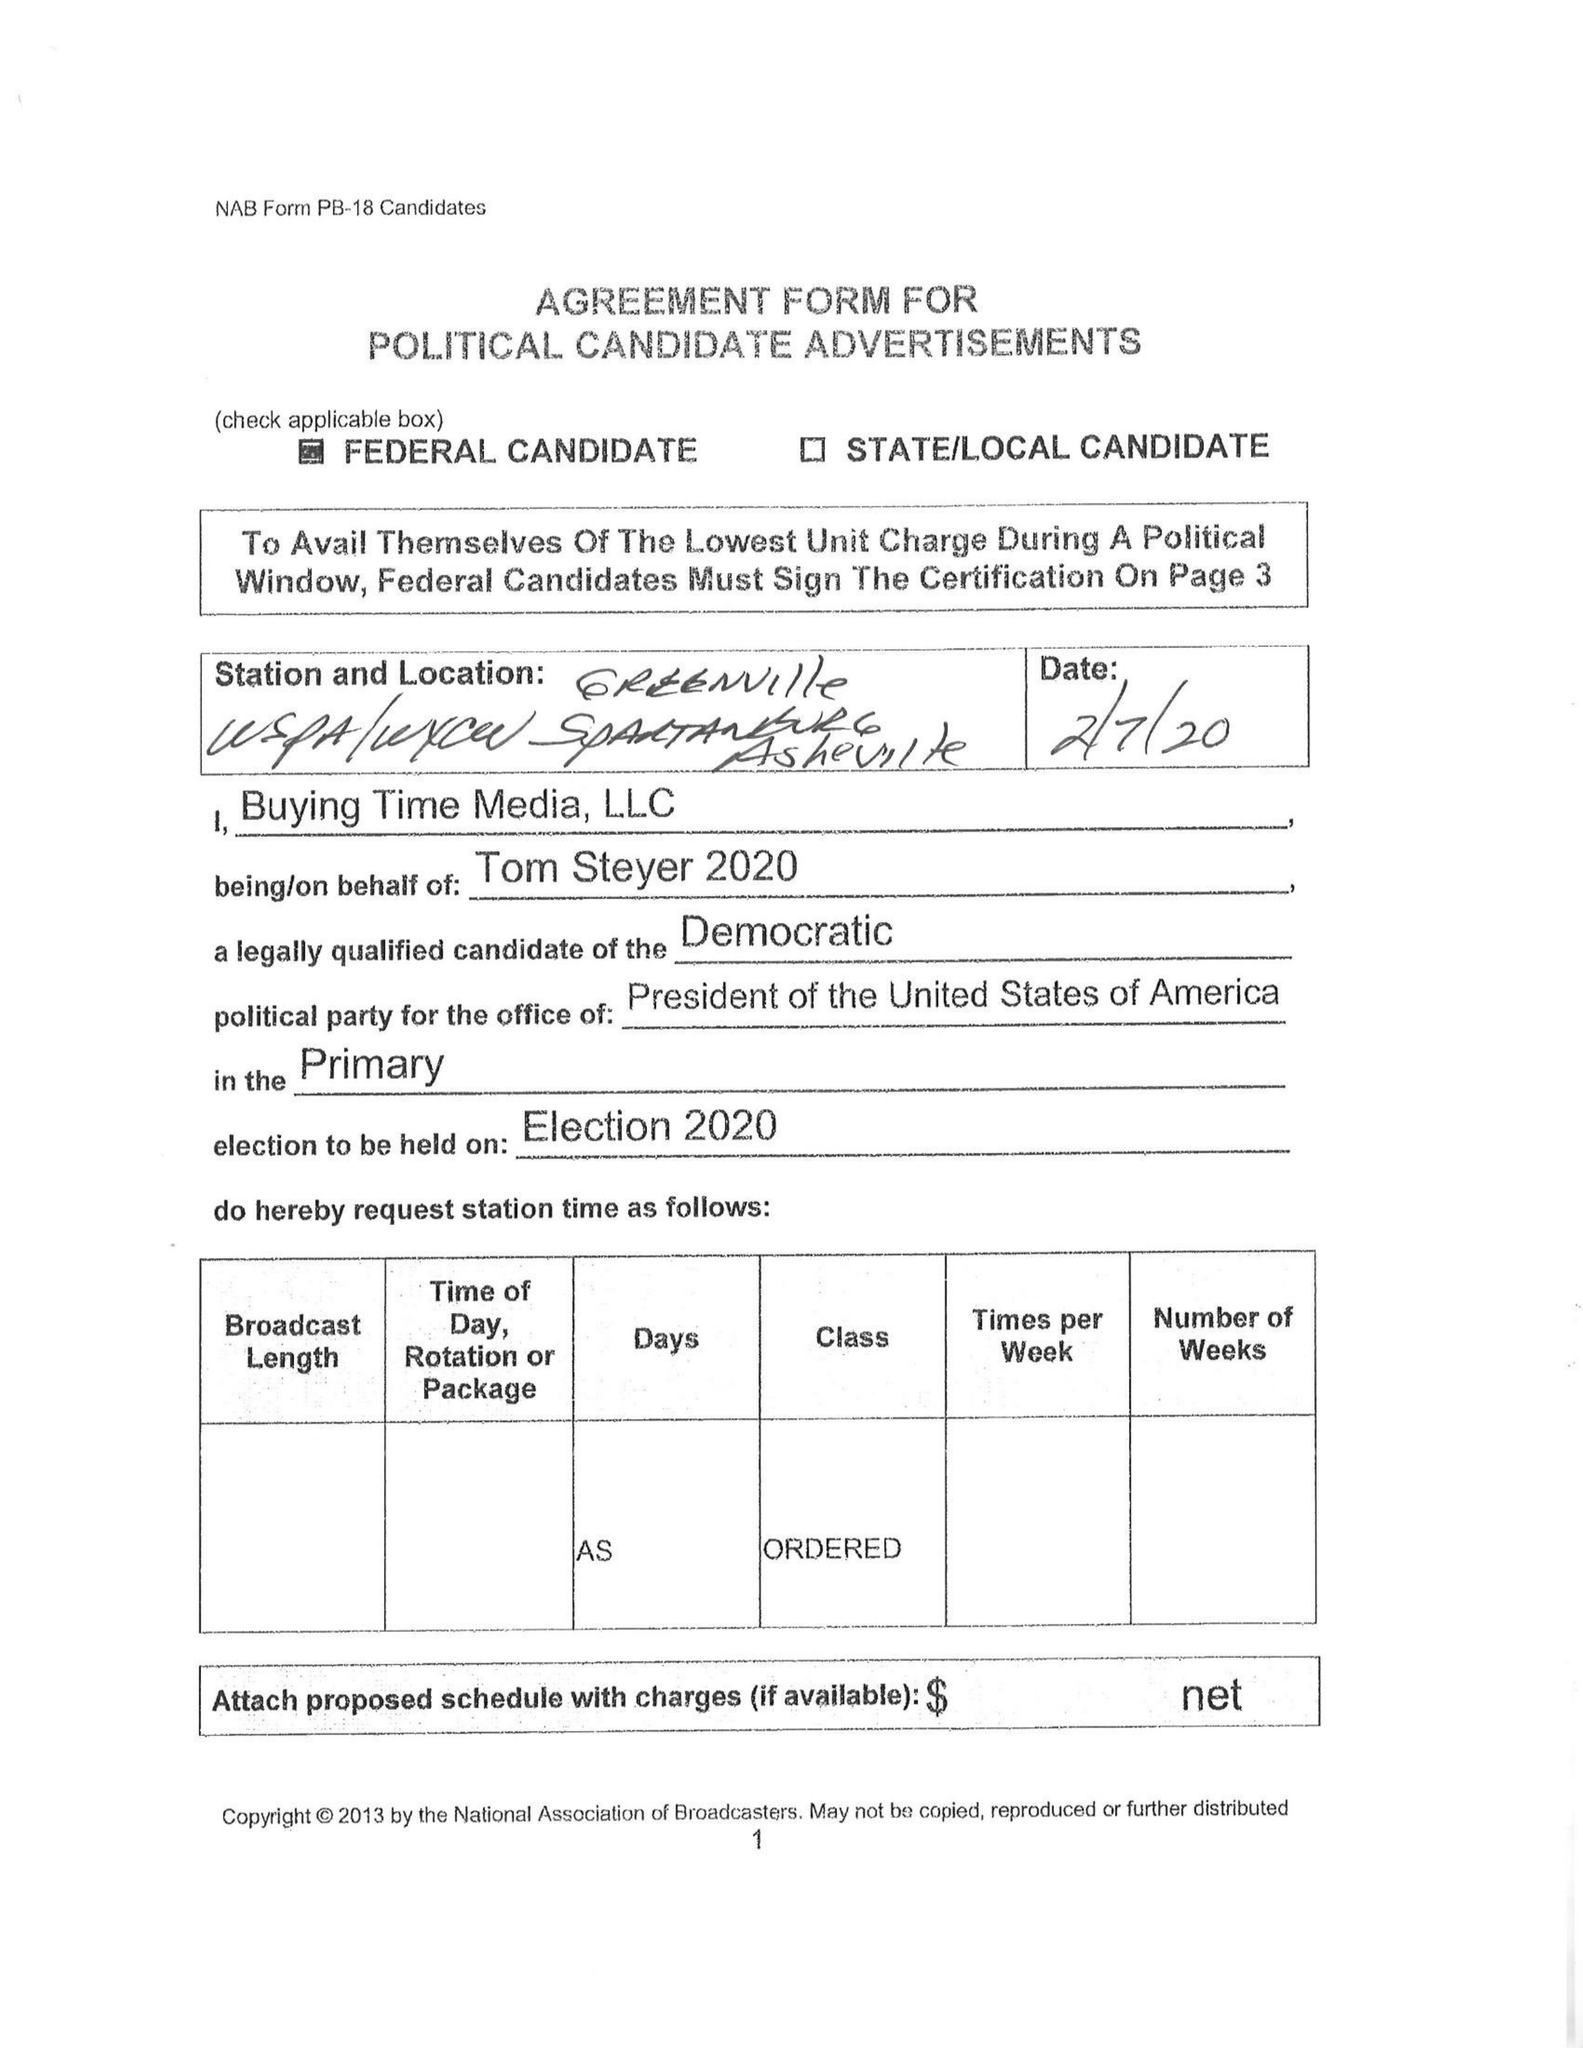What is the value for the contract_num?
Answer the question using a single word or phrase. None 